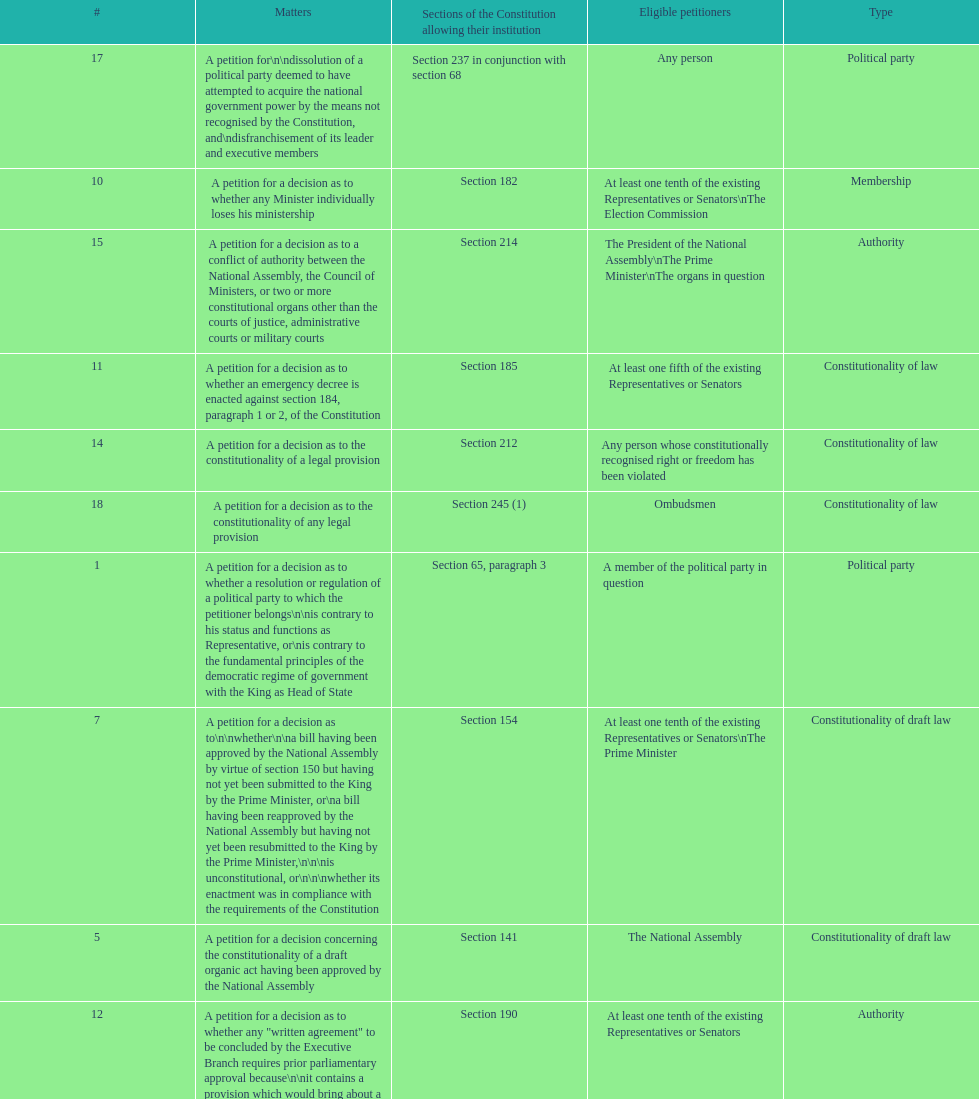How many matters have political party as their "type"? 3. 